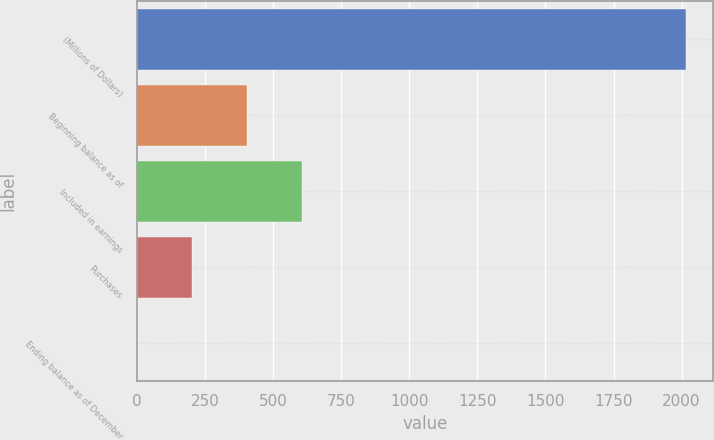<chart> <loc_0><loc_0><loc_500><loc_500><bar_chart><fcel>(Millions of Dollars)<fcel>Beginning balance as of<fcel>Included in earnings<fcel>Purchases<fcel>Ending balance as of December<nl><fcel>2016<fcel>404<fcel>605.5<fcel>202.5<fcel>1<nl></chart> 